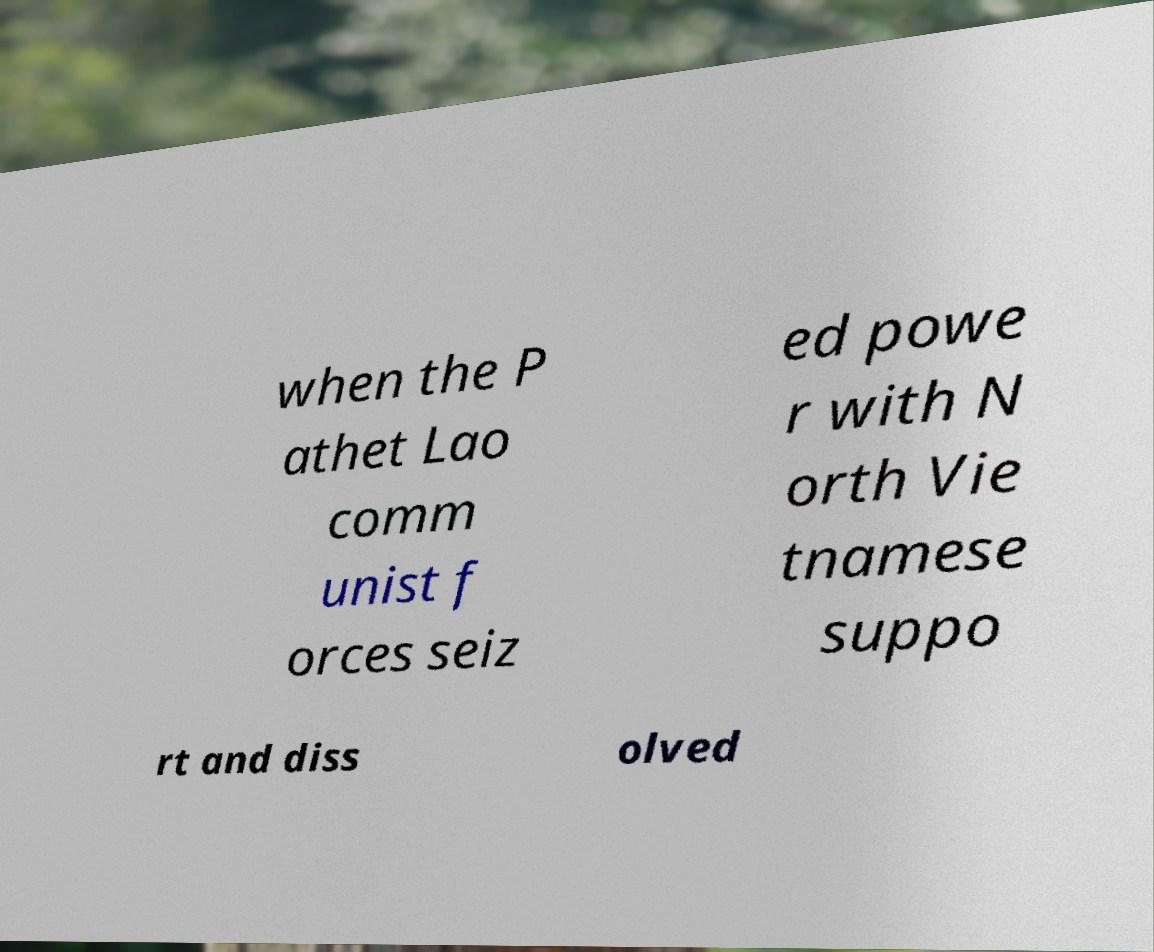Can you accurately transcribe the text from the provided image for me? when the P athet Lao comm unist f orces seiz ed powe r with N orth Vie tnamese suppo rt and diss olved 